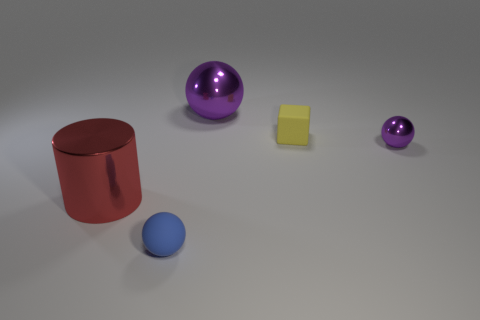What shape is the small metal object that is the same color as the big ball?
Provide a succinct answer. Sphere. There is a metal sphere in front of the tiny yellow matte block; does it have the same color as the large sphere?
Offer a very short reply. Yes. What number of matte objects are right of the sphere that is in front of the cylinder?
Provide a succinct answer. 1. What color is the metallic sphere that is the same size as the yellow matte thing?
Keep it short and to the point. Purple. There is a big object behind the tiny purple object; what is it made of?
Provide a short and direct response. Metal. There is a object that is both to the left of the cube and behind the small purple thing; what material is it?
Provide a succinct answer. Metal. Do the matte object to the right of the blue sphere and the large ball have the same size?
Provide a short and direct response. No. What is the shape of the yellow rubber thing?
Make the answer very short. Cube. How many large purple metallic things have the same shape as the blue object?
Keep it short and to the point. 1. What number of small objects are to the left of the small yellow matte thing and behind the metallic cylinder?
Offer a terse response. 0. 